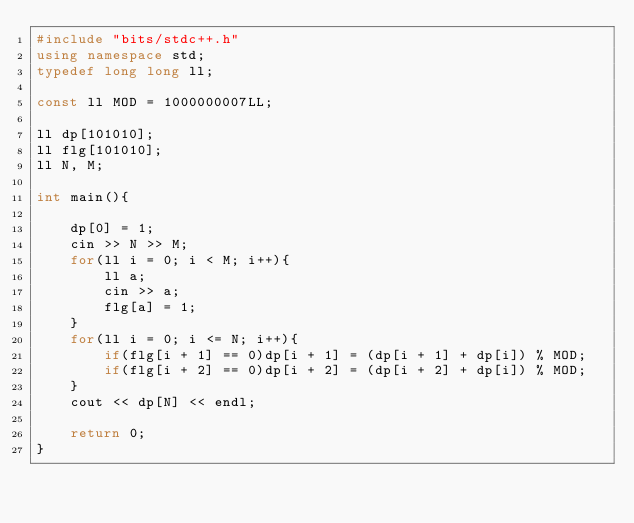<code> <loc_0><loc_0><loc_500><loc_500><_C++_>#include "bits/stdc++.h"
using namespace std;
typedef long long ll;

const ll MOD = 1000000007LL;

ll dp[101010];
ll flg[101010];
ll N, M;

int main(){

    dp[0] = 1;
    cin >> N >> M;
    for(ll i = 0; i < M; i++){
        ll a;
        cin >> a;
        flg[a] = 1;
    }
    for(ll i = 0; i <= N; i++){
        if(flg[i + 1] == 0)dp[i + 1] = (dp[i + 1] + dp[i]) % MOD;
        if(flg[i + 2] == 0)dp[i + 2] = (dp[i + 2] + dp[i]) % MOD;
    }
    cout << dp[N] << endl;

    return 0;
}</code> 